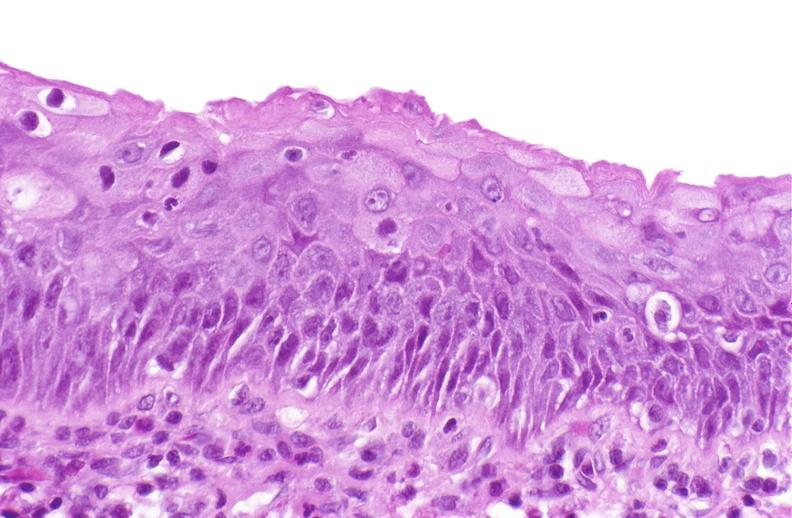does gastrointestinal show squamous metaplasia, renal pelvis due to nephrolithiasis?
Answer the question using a single word or phrase. No 